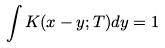Convert formula to latex. <formula><loc_0><loc_0><loc_500><loc_500>\int K ( x - y ; T ) d y = 1</formula> 